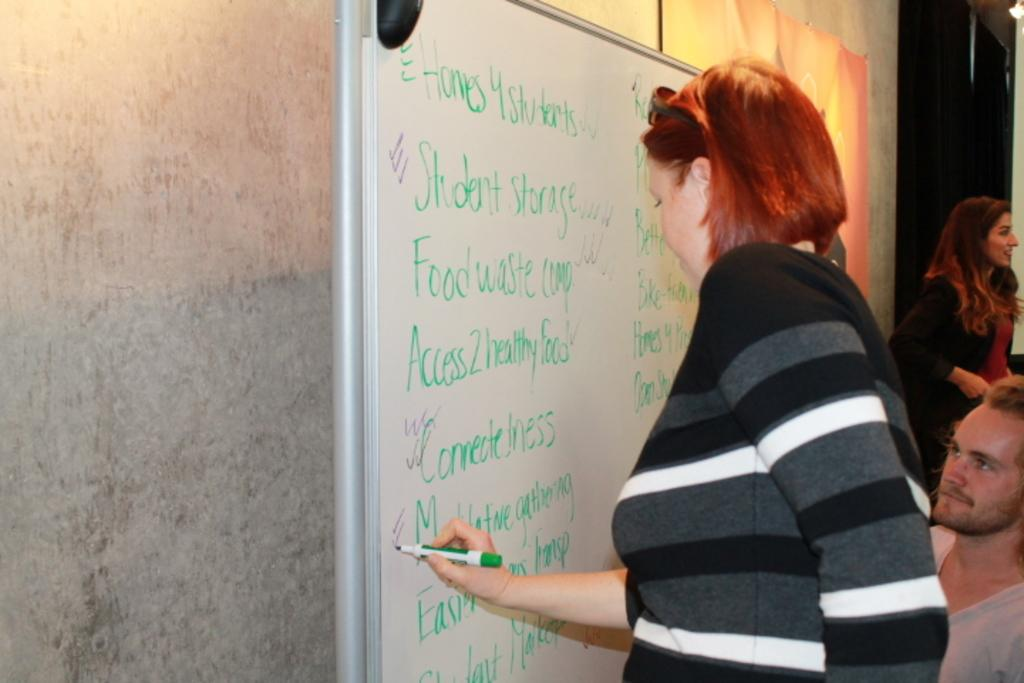<image>
Write a terse but informative summary of the picture. A woman writes on a board with the upper left word that reads, "homes." 